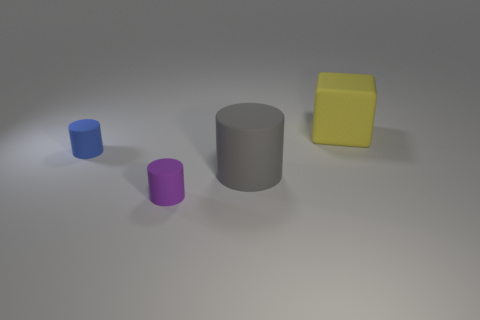The thing that is both on the right side of the tiny purple thing and behind the large cylinder has what shape?
Provide a succinct answer. Cube. How many big yellow rubber things have the same shape as the tiny blue matte thing?
Provide a short and direct response. 0. The gray cylinder that is made of the same material as the big yellow thing is what size?
Keep it short and to the point. Large. Is the number of small metal blocks greater than the number of large yellow objects?
Make the answer very short. No. There is a tiny matte cylinder in front of the tiny blue matte cylinder; what is its color?
Keep it short and to the point. Purple. There is a rubber thing that is both on the right side of the tiny purple rubber object and in front of the blue matte cylinder; what size is it?
Your answer should be very brief. Large. What number of blue things have the same size as the purple matte object?
Keep it short and to the point. 1. There is a large gray object that is the same shape as the purple matte object; what material is it?
Provide a short and direct response. Rubber. Do the big gray matte thing and the purple thing have the same shape?
Provide a succinct answer. Yes. There is a yellow matte block; how many yellow rubber things are to the left of it?
Offer a very short reply. 0. 